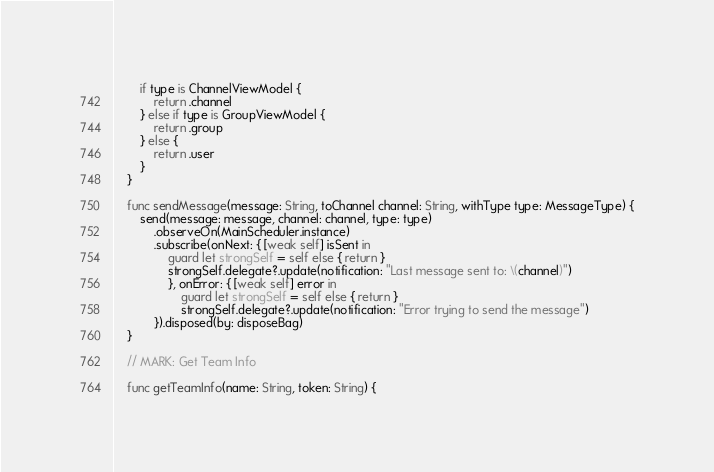<code> <loc_0><loc_0><loc_500><loc_500><_Swift_>        if type is ChannelViewModel {
            return .channel
        } else if type is GroupViewModel {
            return .group
        } else {
            return .user
        }
    }
    
    func sendMessage(message: String, toChannel channel: String, withType type: MessageType) {
        send(message: message, channel: channel, type: type)
            .observeOn(MainScheduler.instance)
            .subscribe(onNext: { [weak self] isSent in
                guard let strongSelf = self else { return }
                strongSelf.delegate?.update(notification: "Last message sent to: \(channel)")
                }, onError: { [weak self] error in
                    guard let strongSelf = self else { return }
                    strongSelf.delegate?.update(notification: "Error trying to send the message")
            }).disposed(by: disposeBag)
    }
    
    // MARK: Get Team Info
    
    func getTeamInfo(name: String, token: String) {</code> 